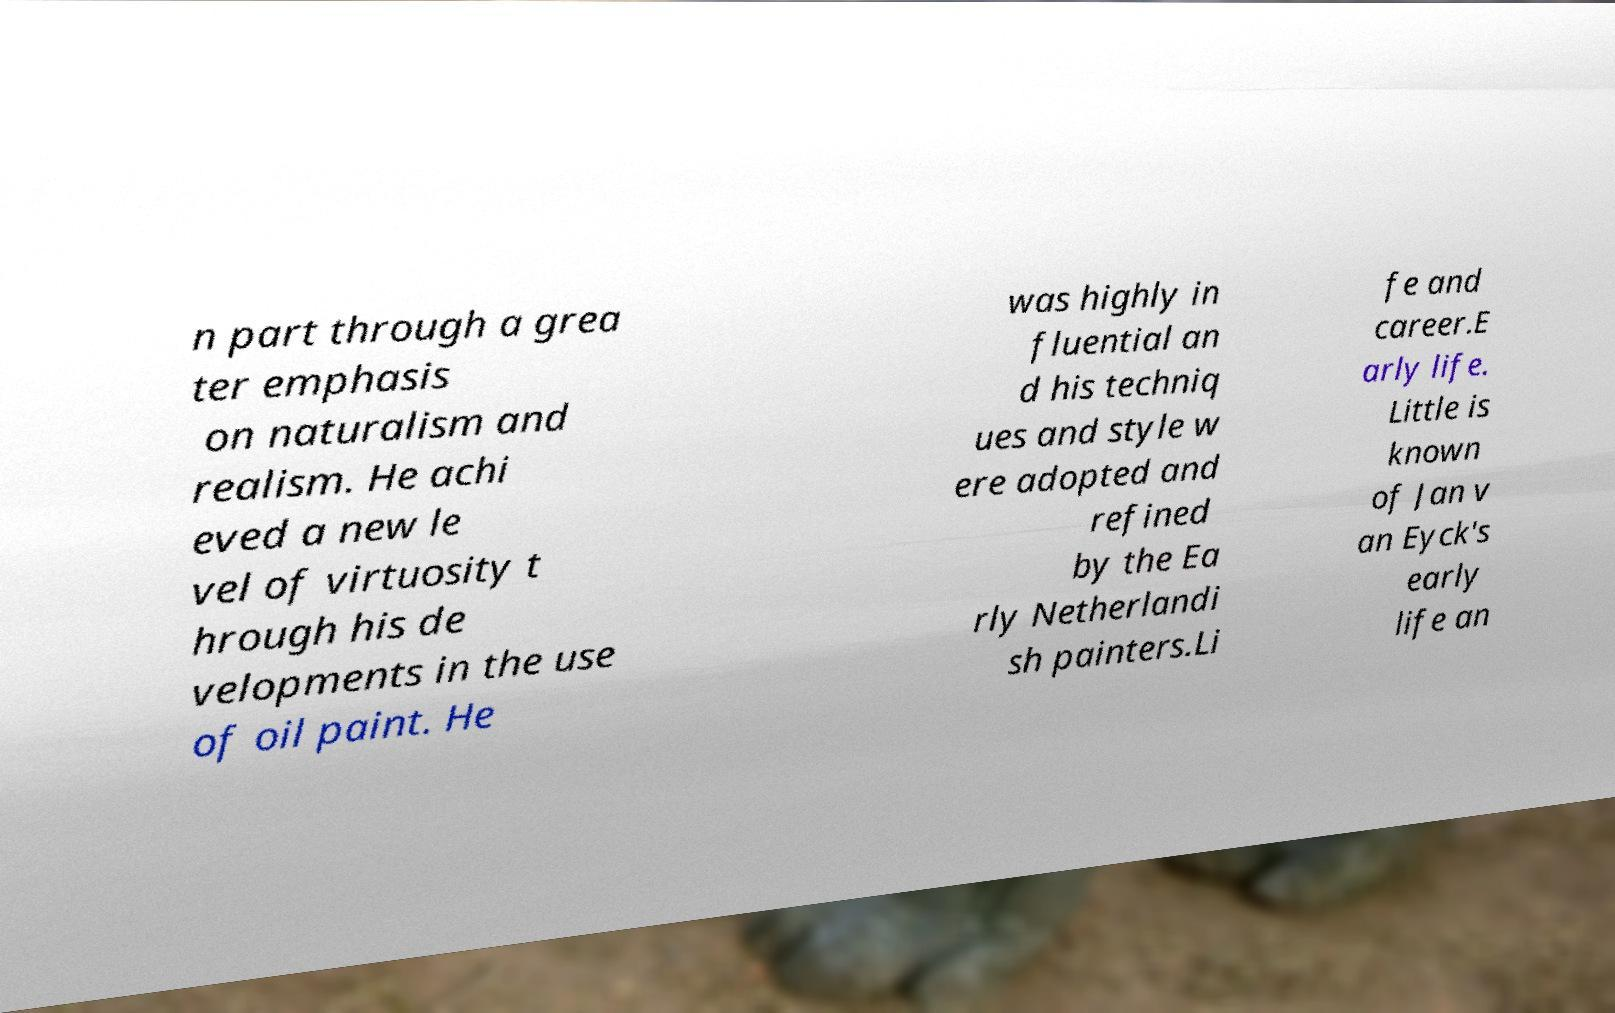Could you extract and type out the text from this image? n part through a grea ter emphasis on naturalism and realism. He achi eved a new le vel of virtuosity t hrough his de velopments in the use of oil paint. He was highly in fluential an d his techniq ues and style w ere adopted and refined by the Ea rly Netherlandi sh painters.Li fe and career.E arly life. Little is known of Jan v an Eyck's early life an 